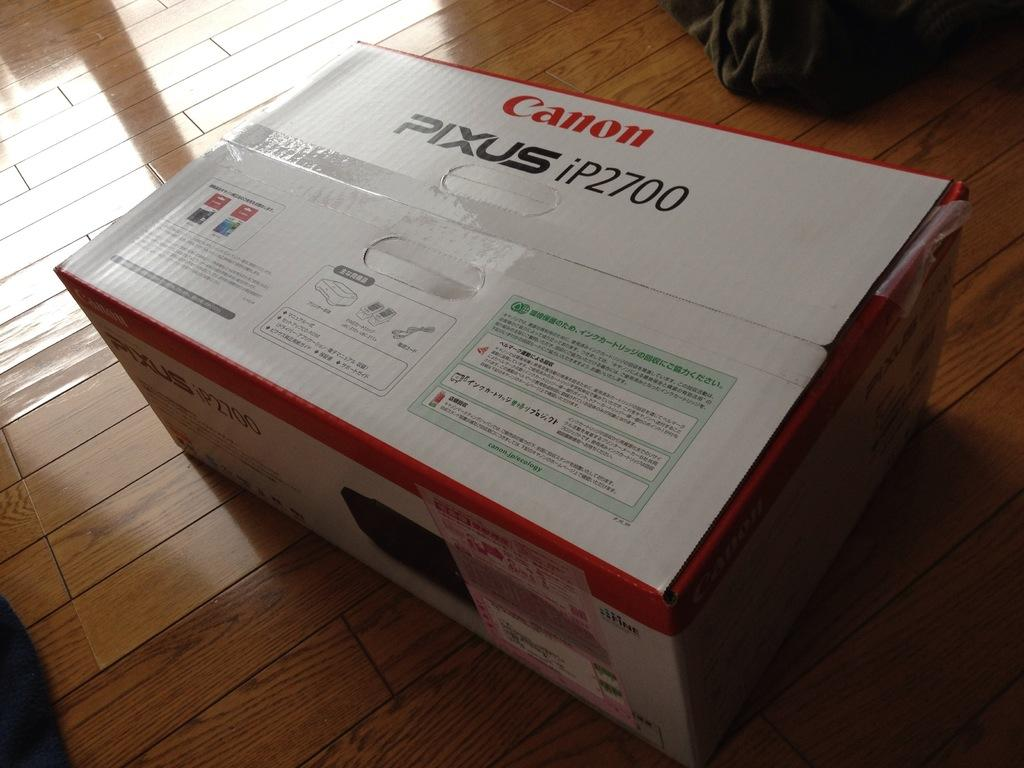<image>
Create a compact narrative representing the image presented. a box on the floor that is labeled as 'canon pixus ip2700' 